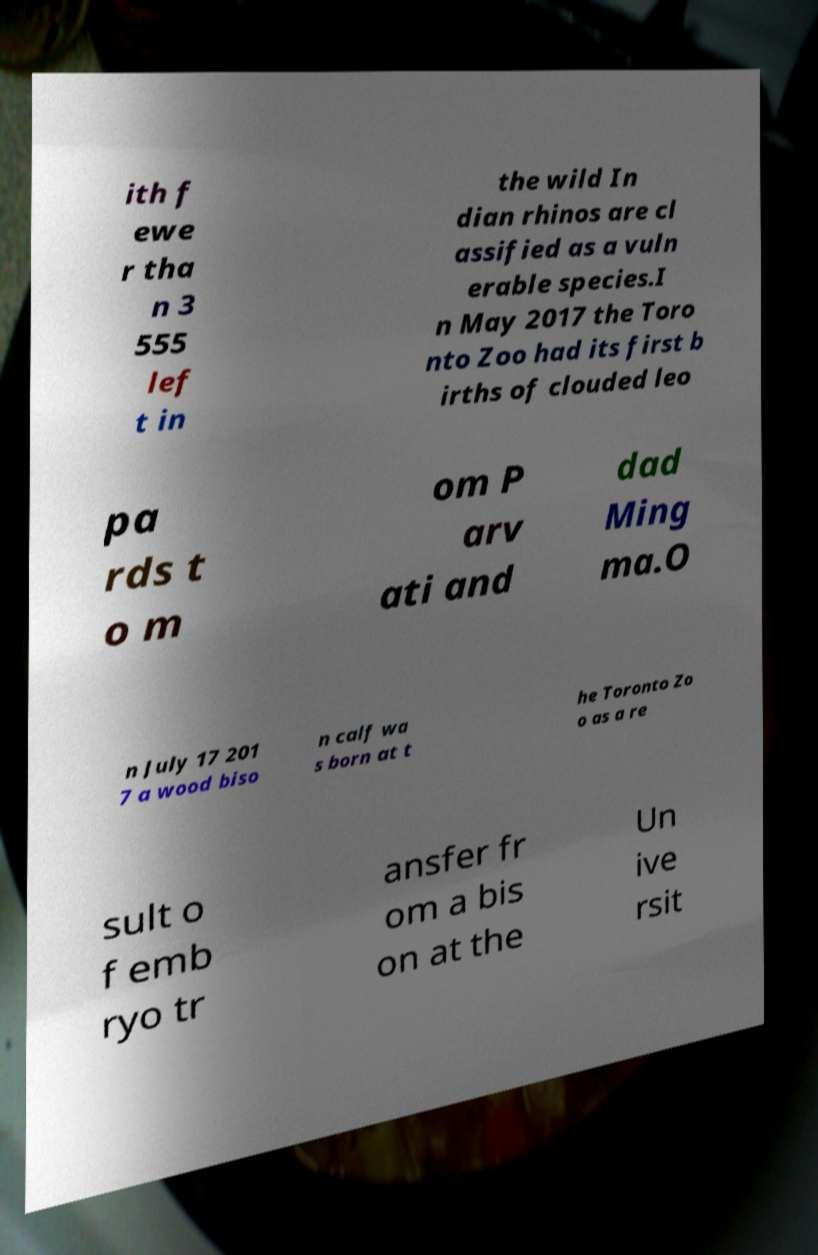Could you assist in decoding the text presented in this image and type it out clearly? ith f ewe r tha n 3 555 lef t in the wild In dian rhinos are cl assified as a vuln erable species.I n May 2017 the Toro nto Zoo had its first b irths of clouded leo pa rds t o m om P arv ati and dad Ming ma.O n July 17 201 7 a wood biso n calf wa s born at t he Toronto Zo o as a re sult o f emb ryo tr ansfer fr om a bis on at the Un ive rsit 